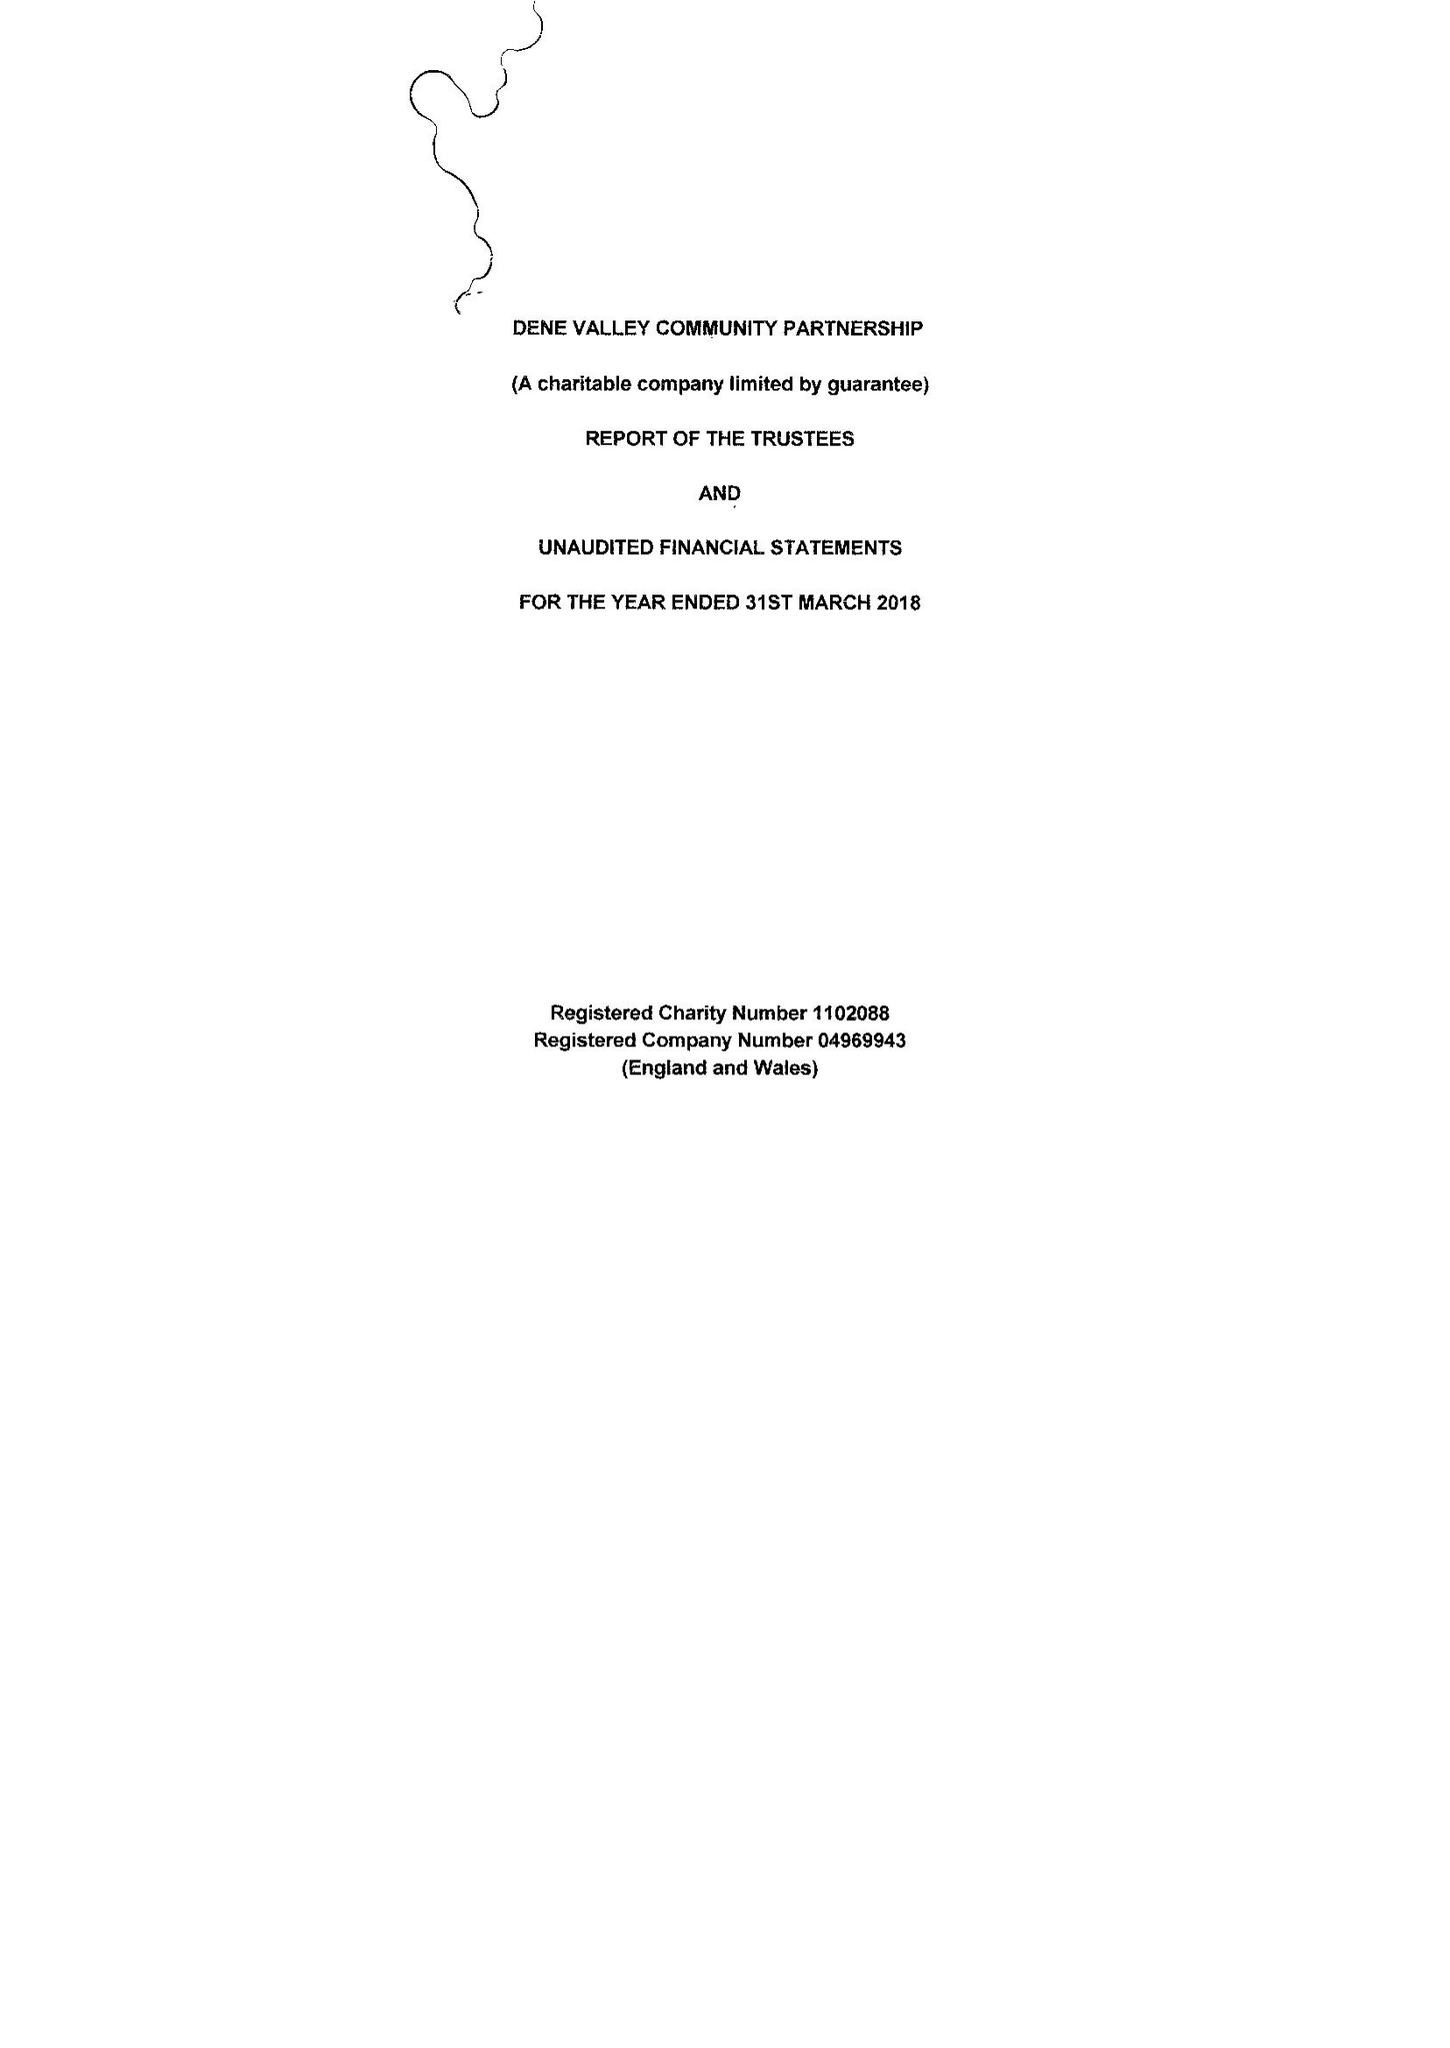What is the value for the address__postcode?
Answer the question using a single word or phrase. DL14 8TD 